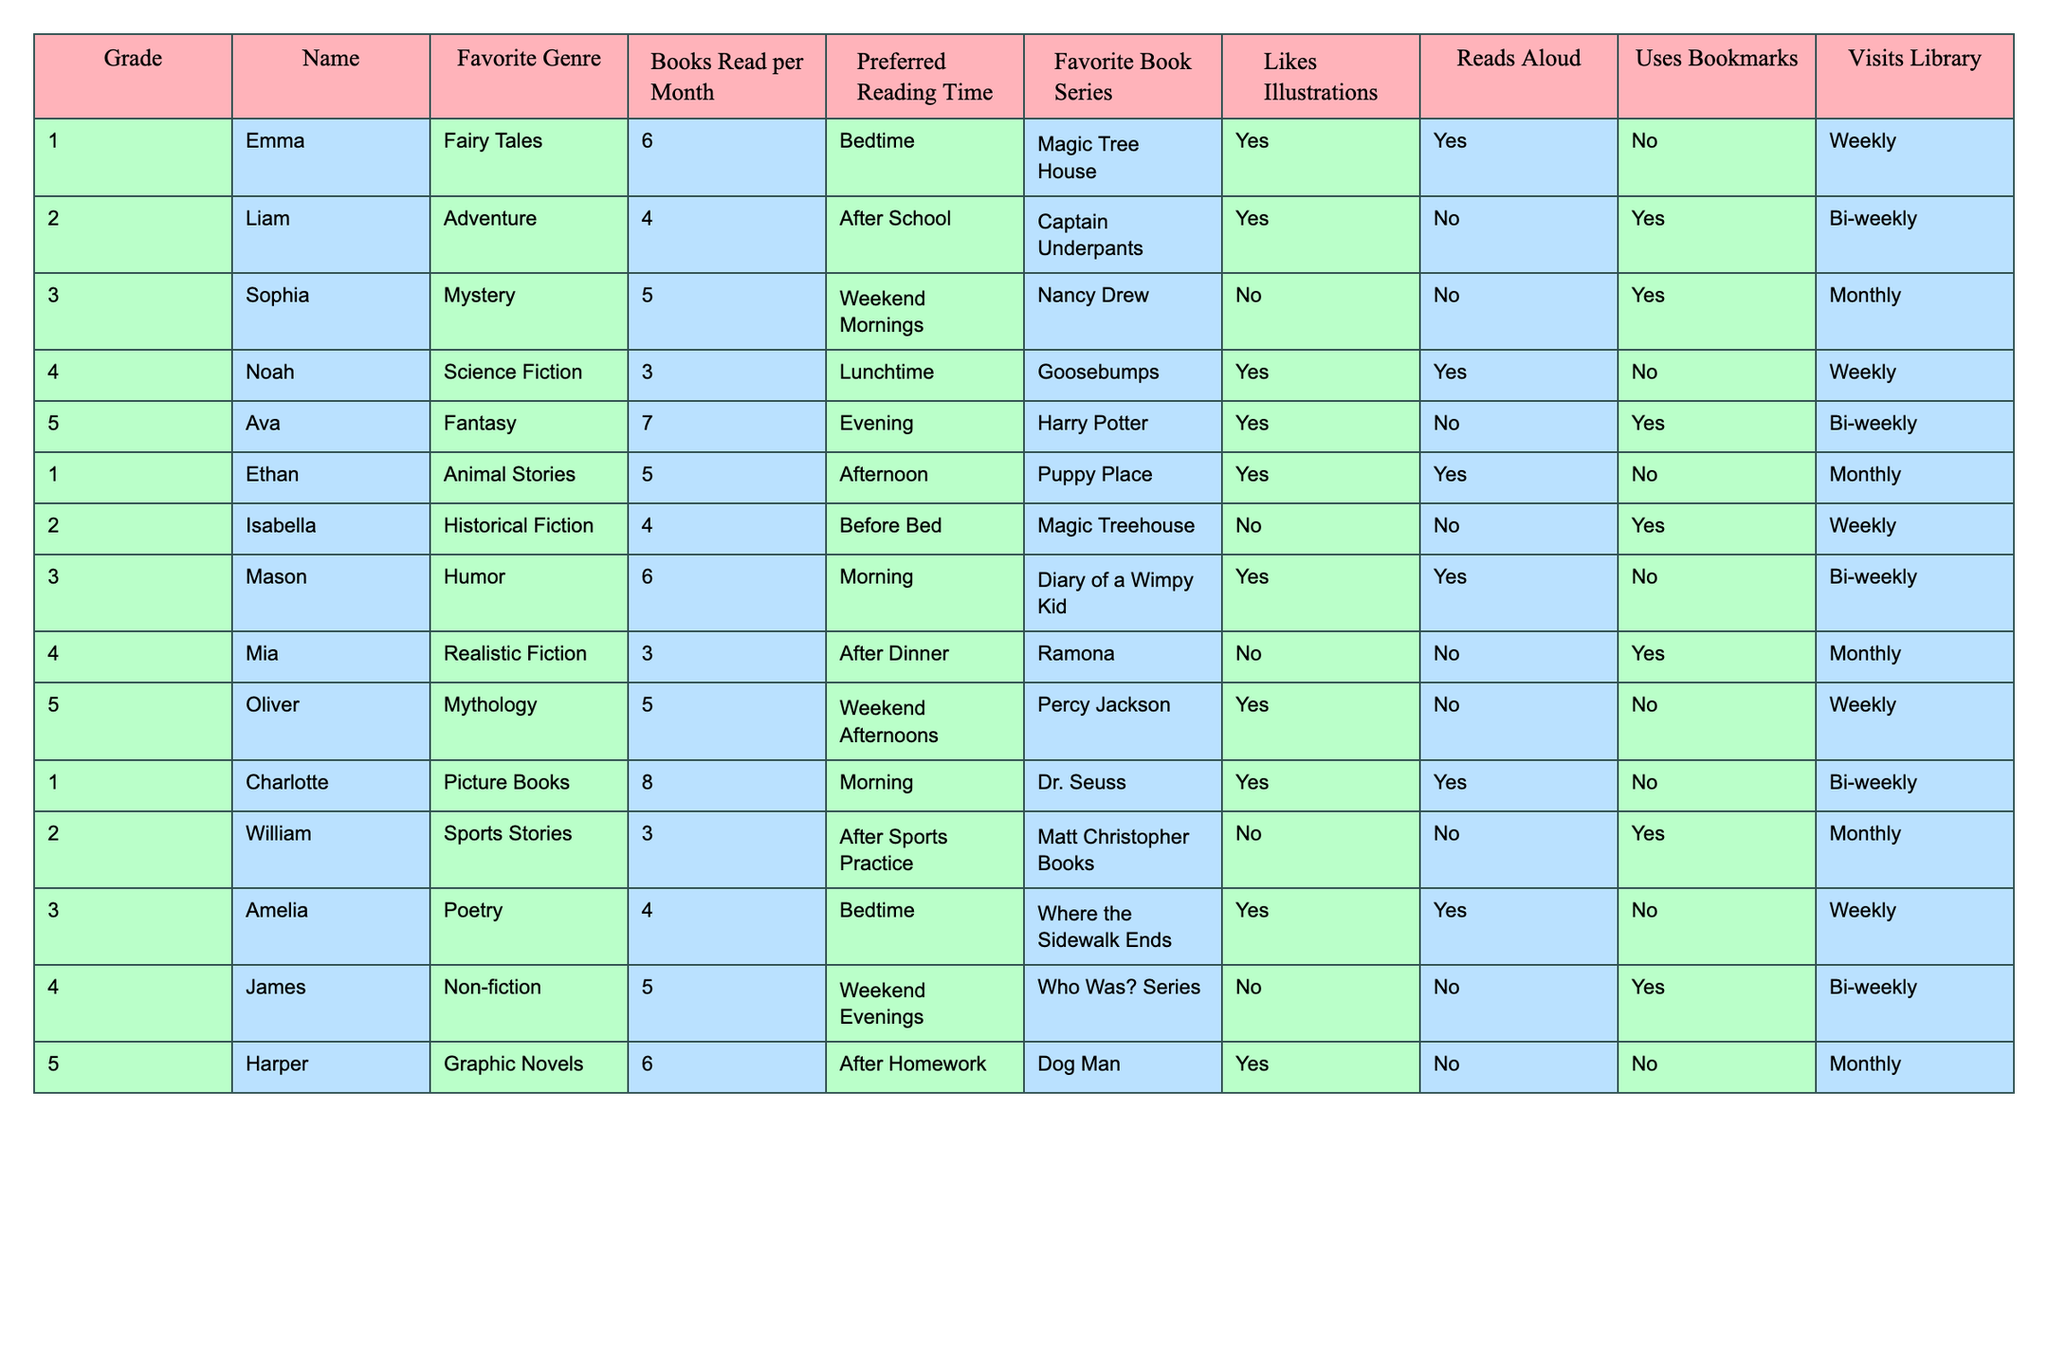What is Emma's favorite genre? From the table, Emma is listed under Grade 1, and her favorite genre is noted as Fairy Tales.
Answer: Fairy Tales How many books does Ava read per month? Ava, who is in Grade 5, reads 7 books per month according to the table.
Answer: 7 Which student likes illustrations and reads aloud? Examining the table, both Emma and Charlotte like illustrations and read aloud, as per their entries.
Answer: Emma and Charlotte What is the most common preferred reading time among the students? Looking at the data, the preferred reading times are varied, but the most common times appear to be Bedtime and After School, as listed by multiple students.
Answer: Bedtime and After School How many students in Grade 4 read non-fiction books? Checking the table, only one student, James, from Grade 4 reads non-fiction books.
Answer: 1 What is the average number of books read per month by students in Grade 3? In Grade 3, Sophia reads 5 books, Mason reads 6 books, and Amelia reads 4 books. Adding these (5 + 6 + 4 = 15) and dividing by the 3 students results in an average of 15 / 3 = 5.
Answer: 5 Do all students use bookmarks? By reviewing the table, it is clear that some students do not use bookmarks, such as Emma and Ava. Therefore, not all students use bookmarks.
Answer: No Which grade has students with the highest number of books read per month? By reviewing the table, Charlotte in Grade 1 reads 8 books, which is higher than any other entries. Grade 1 has the highest books read per month.
Answer: Grade 1 How many students prefer graphic novels? Only one student, Harper, prefers graphic novels according to the table.
Answer: 1 If a student visits the library weekly, which grades are represented? Checking the table reveals that Emma and Noah, both from Grades 1 and 4 respectively, visit the library weekly. Thus, Grade 1 and Grade 4 are represented.
Answer: Grade 1 and Grade 4 